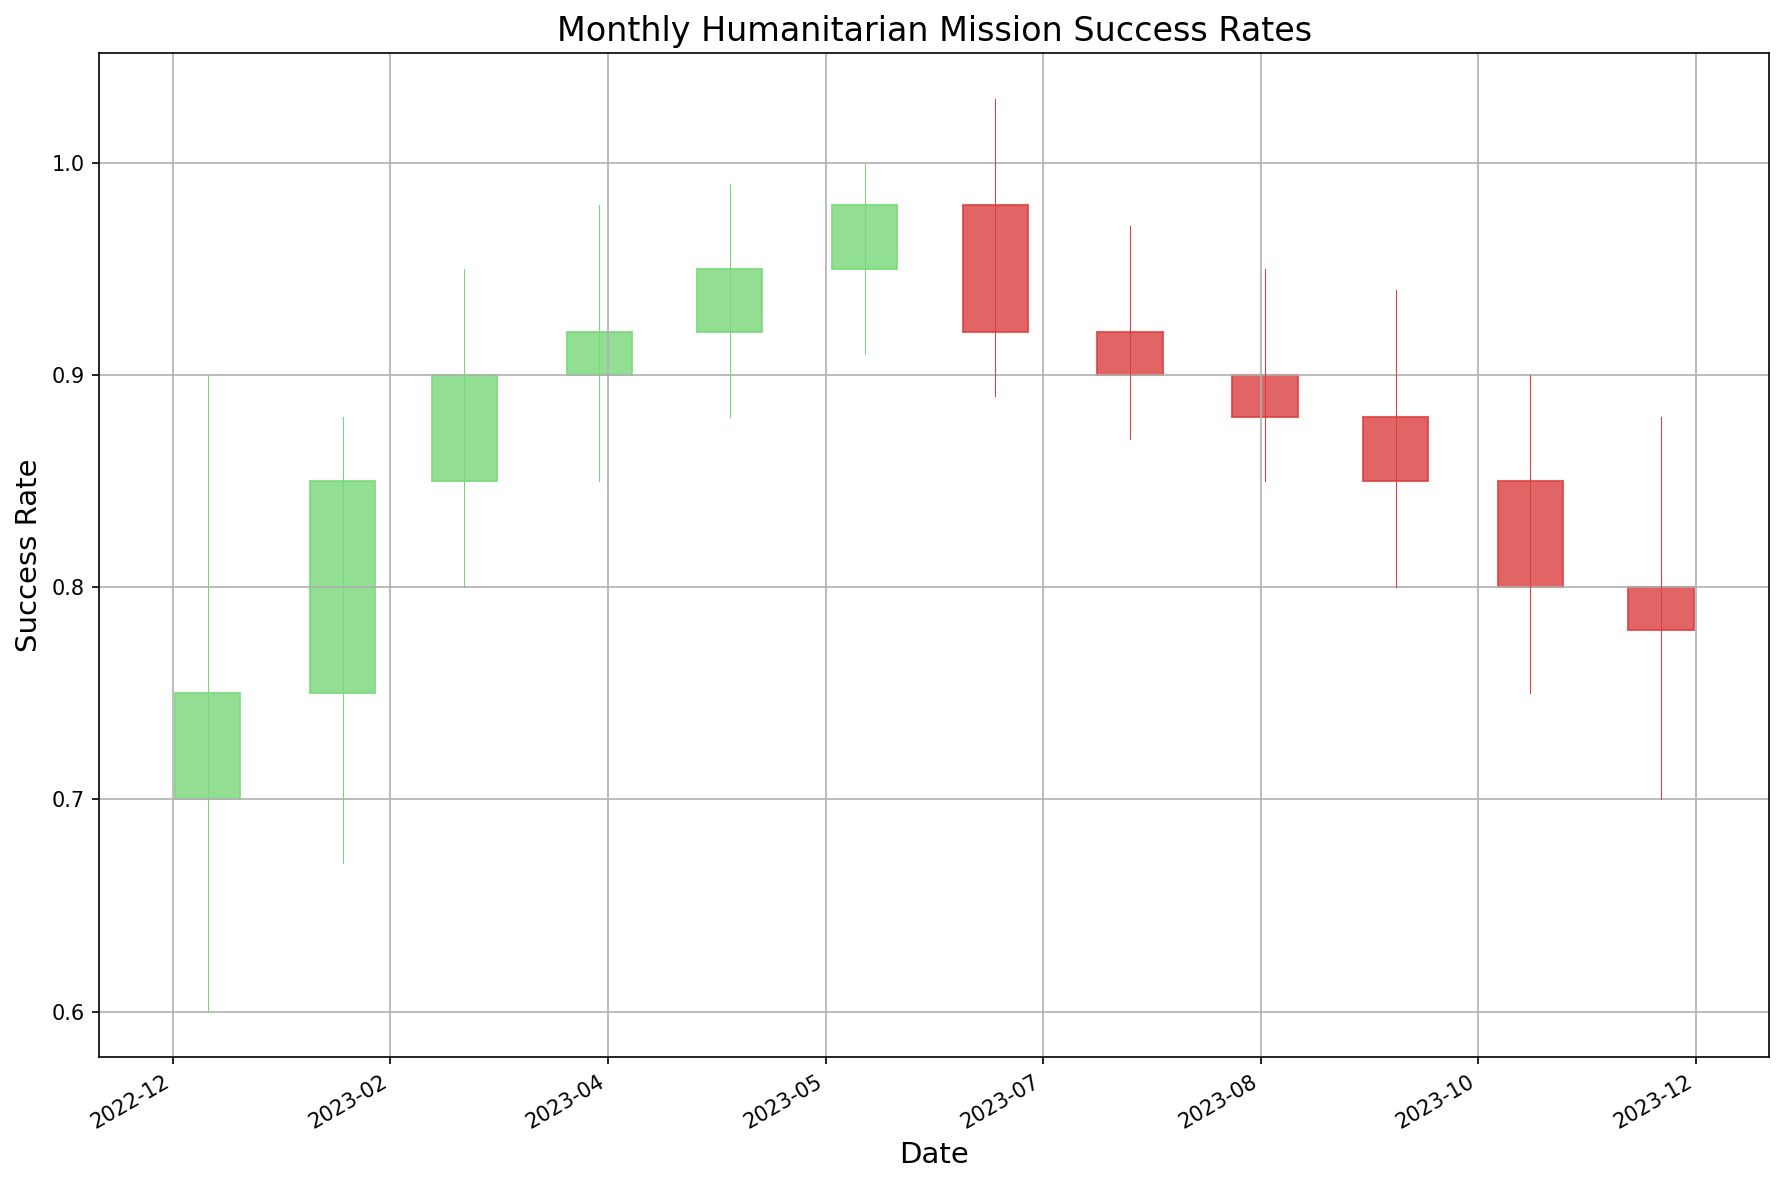What's the success rate trend from January 2023 to June 2023? The success rates (closing values) for the months from January to June 2023 are: January (0.75), February (0.85), March (0.90), April (0.92), May (0.95), and June (0.98). The trend indicates an increasing success rate every month during this period. The successive increment illustrates a positive trend.
Answer: Increasing Was there any month when the success rate decreased, then increased, and then decreased again over three consecutive months? From the data, a pattern of decrease-increase-decrease over three consecutive months is from July 2023 to September 2023. Specifically, the closing value decreased from June to July (0.98 to 0.92), then increased from July to August (0.92 to 0.90), and finally decreased again from August to September (0.90 to 0.88).
Answer: Yes, July to September Which month had the highest success rate, and how does it compare to the month with the lowest success rate? June 2023 had the highest success rate with a closing value of 0.98, while November 2023 had the lowest success rate with a closing value of 0.80. The difference between these values is 0.18 (0.98 - 0.80).
Answer: June had the highest, 0.18 higher than November How many months had a success rate (closing value) above 0.90? By inspecting the candlestick chart, the months of March (0.90), April (0.92), May (0.95), June (0.98), and July (0.92) have closing values above 0.90. Therefore, there are five months that met this criterion.
Answer: Five What is the average success rate for the last three months of 2023? The closing values for the last three months (October, November, December) are 0.85, 0.80, and 0.78 respectively. To find the average: (0.85 + 0.80 + 0.78) / 3 = 2.43 / 3 = 0.81.
Answer: 0.81 Which months had a higher success rate at closing than at opening in 2023? By comparing the opening and closing values, the months where closing values are higher than opening values are January (0.75 > 0.70), February (0.85 > 0.75), March (0.90 > 0.85), April (0.92 > 0.90), May (0.95 > 0.92), June (0.98 > 0.95), and October (0.85 > 0.88).
Answer: January, February, March, April, May, June, October During which month did the actual success rate (i.e., closing value) deviate the most from its opening value, and what was this deviation? To find the month with the largest deviation, subtract the opening value from the closing value for each month and compare: January (0.75-0.70=0.05), February (0.85-0.75=0.10), March (0.90-0.85=0.05), April (0.92-0.90=0.02), May (0.95-0.92=0.03), June (0.98-0.95=0.03), July (0.92-0.98=-0.06), August (0.90-0.92=-0.02), September (0.88-0.90=-0.02), October (0.85-0.88=-0.03), November (0.80-0.85=-0.05), December (0.78-0.80=-0.02). February shows the largest positive deviation with 0.10.
Answer: February, 0.10 Which month showed the sharpest drop in success rates compared to the previous month? By comparing the closing values month-on-month, July had the sharpest drop from June, with a change from 0.98 to 0.92, a decline of 0.06.
Answer: July Which months show a candlestick with prominent green color, and what does that color indicate? Months where the closing value is higher than the opening value produce green candlesticks. These months include January, February, March, April, May, June, and October, indicating an increase in success rate over those months.
Answer: January, February, March, April, May, June, October; increase in success rate 